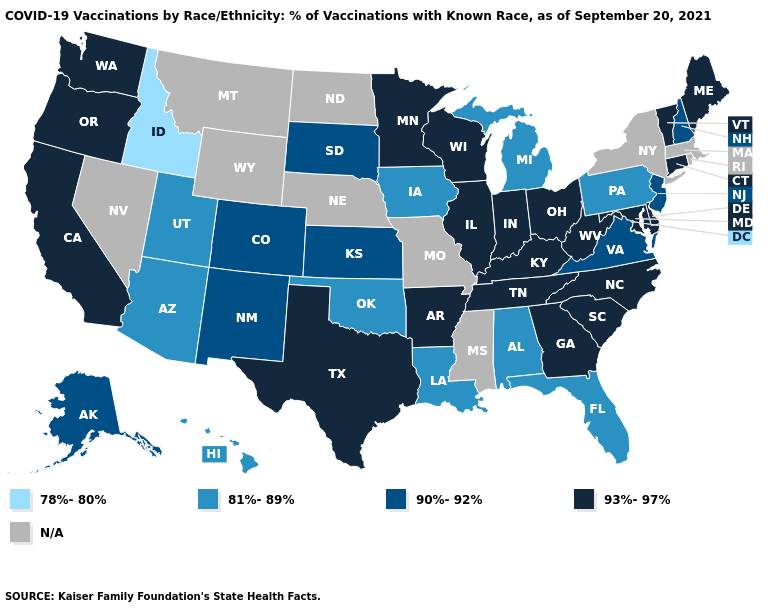What is the value of Kansas?
Be succinct. 90%-92%. Name the states that have a value in the range 93%-97%?
Keep it brief. Arkansas, California, Connecticut, Delaware, Georgia, Illinois, Indiana, Kentucky, Maine, Maryland, Minnesota, North Carolina, Ohio, Oregon, South Carolina, Tennessee, Texas, Vermont, Washington, West Virginia, Wisconsin. Name the states that have a value in the range 81%-89%?
Short answer required. Alabama, Arizona, Florida, Hawaii, Iowa, Louisiana, Michigan, Oklahoma, Pennsylvania, Utah. What is the lowest value in states that border Wisconsin?
Keep it brief. 81%-89%. Is the legend a continuous bar?
Quick response, please. No. Name the states that have a value in the range 90%-92%?
Keep it brief. Alaska, Colorado, Kansas, New Hampshire, New Jersey, New Mexico, South Dakota, Virginia. Which states have the lowest value in the MidWest?
Quick response, please. Iowa, Michigan. What is the value of Massachusetts?
Write a very short answer. N/A. What is the lowest value in the USA?
Give a very brief answer. 78%-80%. Does Idaho have the lowest value in the USA?
Write a very short answer. Yes. Name the states that have a value in the range 93%-97%?
Give a very brief answer. Arkansas, California, Connecticut, Delaware, Georgia, Illinois, Indiana, Kentucky, Maine, Maryland, Minnesota, North Carolina, Ohio, Oregon, South Carolina, Tennessee, Texas, Vermont, Washington, West Virginia, Wisconsin. What is the value of Louisiana?
Write a very short answer. 81%-89%. What is the value of Minnesota?
Quick response, please. 93%-97%. Name the states that have a value in the range 93%-97%?
Short answer required. Arkansas, California, Connecticut, Delaware, Georgia, Illinois, Indiana, Kentucky, Maine, Maryland, Minnesota, North Carolina, Ohio, Oregon, South Carolina, Tennessee, Texas, Vermont, Washington, West Virginia, Wisconsin. 